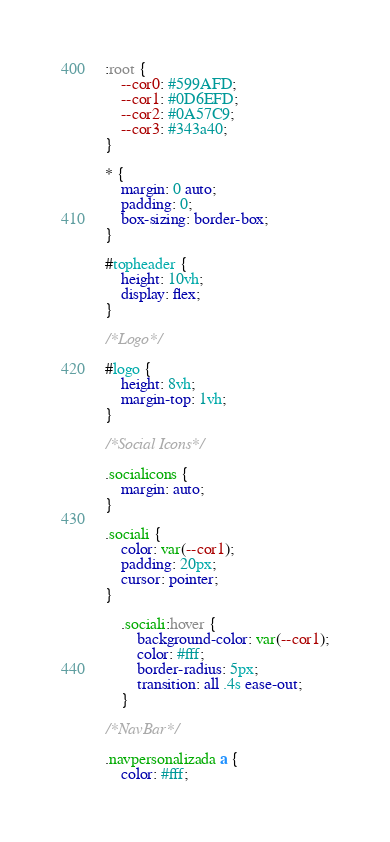<code> <loc_0><loc_0><loc_500><loc_500><_CSS_>
:root {
    --cor0: #599AFD;
    --cor1: #0D6EFD;
    --cor2: #0A57C9;
    --cor3: #343a40;
}

* {
    margin: 0 auto;
    padding: 0;
    box-sizing: border-box;
}

#topheader {
    height: 10vh;
    display: flex;
}

/*Logo*/

#logo {
    height: 8vh;
    margin-top: 1vh;
}

/*Social Icons*/

.socialicons {
    margin: auto;
}

.sociali {
    color: var(--cor1);
    padding: 20px;
    cursor: pointer;
}

    .sociali:hover {
        background-color: var(--cor1);
        color: #fff;
        border-radius: 5px;
        transition: all .4s ease-out;
    }

/*NavBar*/

.navpersonalizada a {
    color: #fff;</code> 